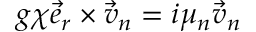<formula> <loc_0><loc_0><loc_500><loc_500>g \chi \vec { e } _ { r } \times \vec { v } _ { n } = i \mu _ { n } \vec { v } _ { n }</formula> 